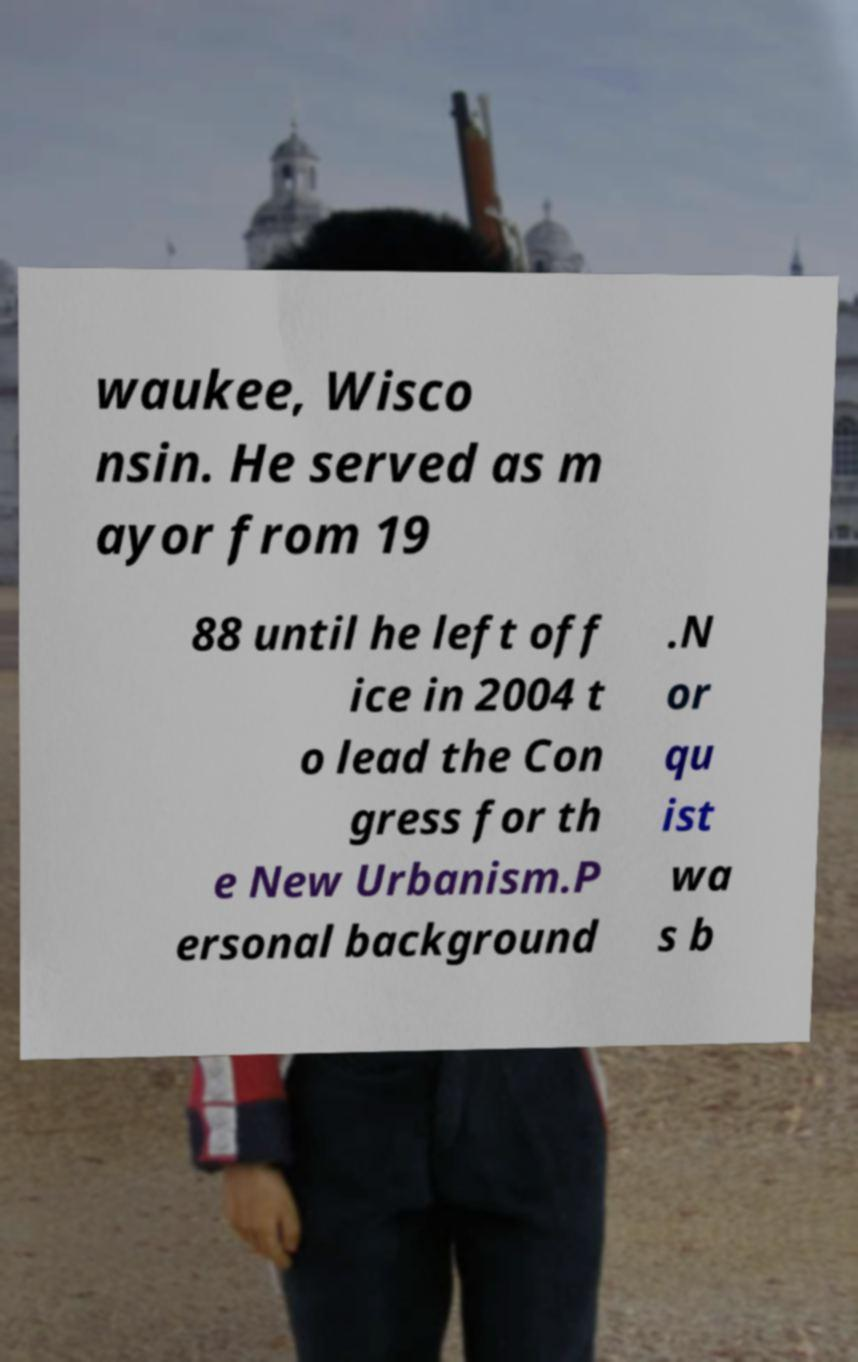There's text embedded in this image that I need extracted. Can you transcribe it verbatim? waukee, Wisco nsin. He served as m ayor from 19 88 until he left off ice in 2004 t o lead the Con gress for th e New Urbanism.P ersonal background .N or qu ist wa s b 